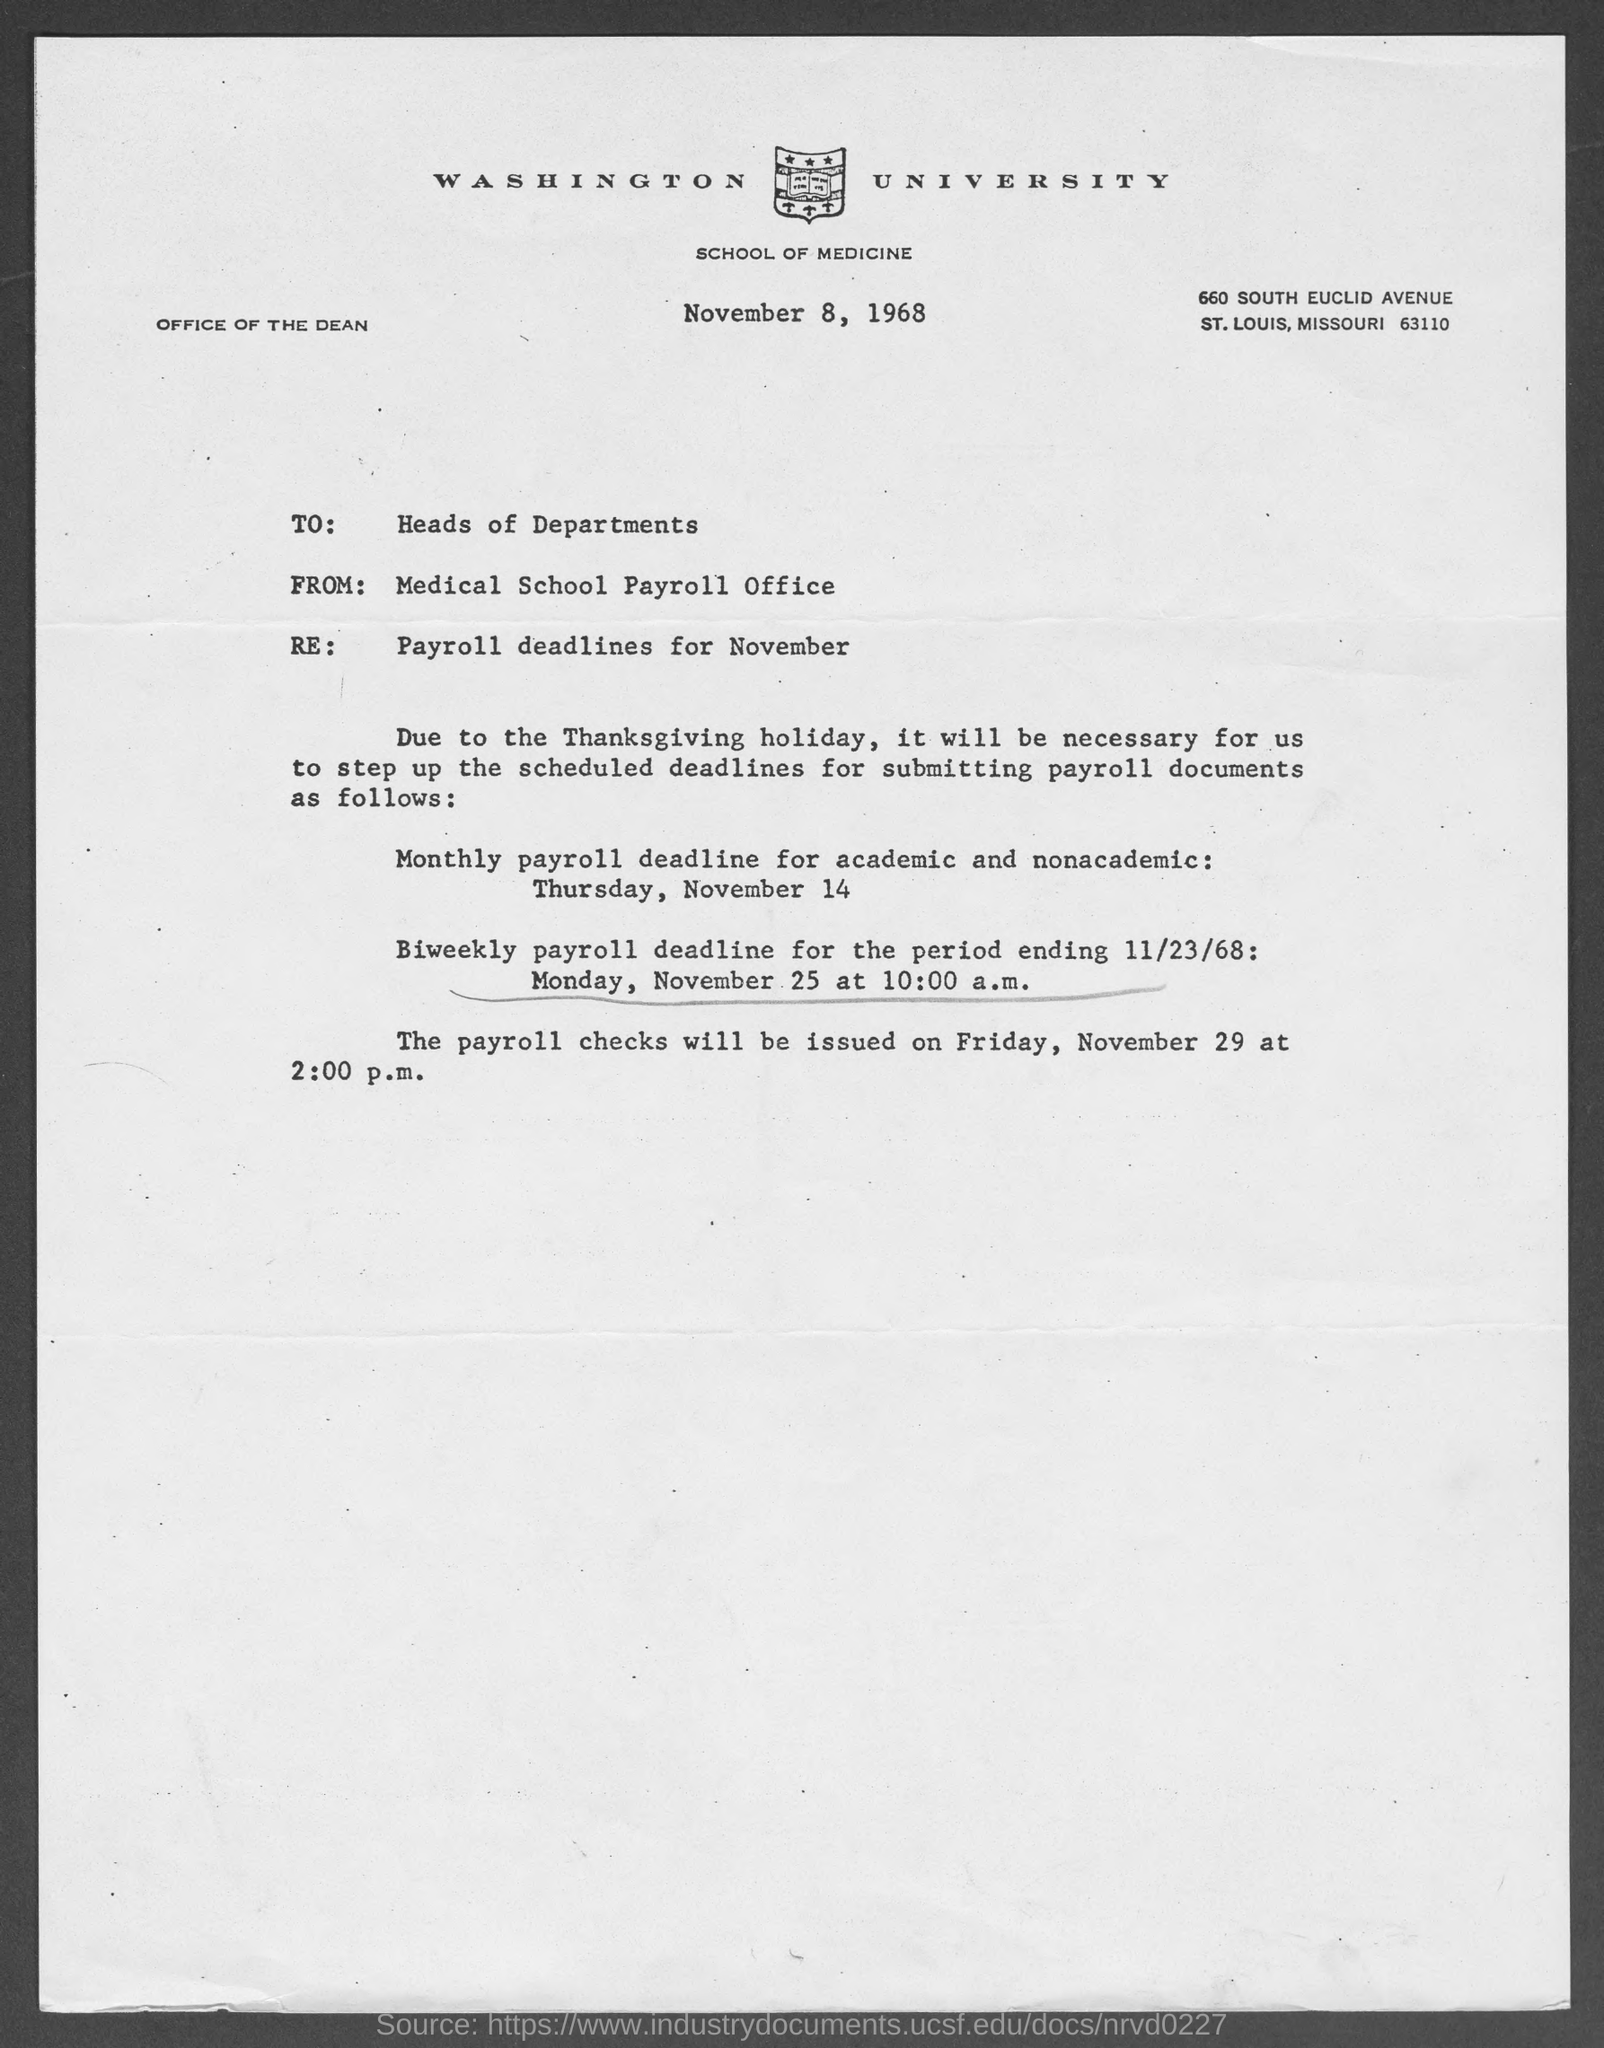To whom the letter is written?
Your answer should be very brief. Heads of Departments. When is the monthly payroll deadline for academic and nonacademic?
Make the answer very short. Thursday, November 14. 